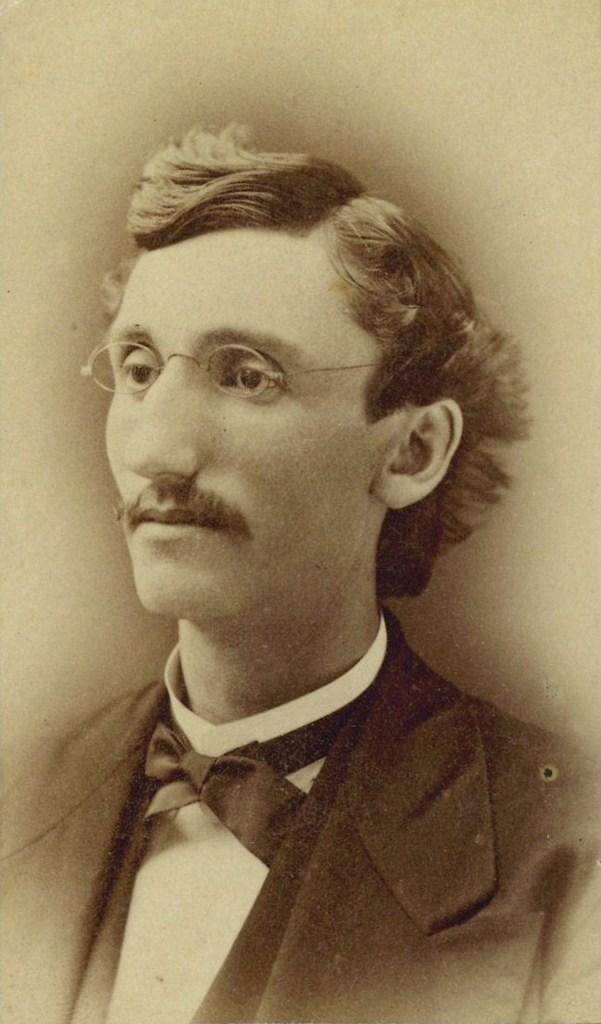What is the color scheme of the image? The image is black and white. Can you describe the person in the image? There is a person in the image. What accessory is the person wearing? The person is wearing spectacles. What type of payment method is being used by the person in the image? There is no indication of any payment method being used in the image, as it only shows a person wearing spectacles. What riddle can be solved by looking at the image? There is no riddle present in the image, as it only features a person wearing spectacles. 